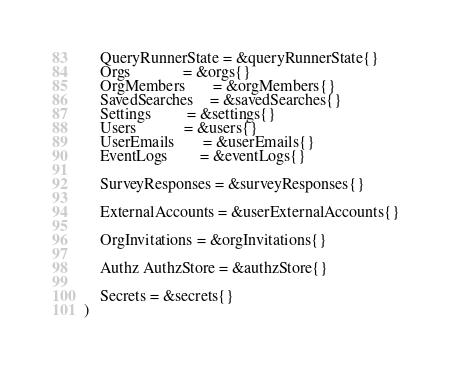Convert code to text. <code><loc_0><loc_0><loc_500><loc_500><_Go_>	QueryRunnerState = &queryRunnerState{}
	Orgs             = &orgs{}
	OrgMembers       = &orgMembers{}
	SavedSearches    = &savedSearches{}
	Settings         = &settings{}
	Users            = &users{}
	UserEmails       = &userEmails{}
	EventLogs        = &eventLogs{}

	SurveyResponses = &surveyResponses{}

	ExternalAccounts = &userExternalAccounts{}

	OrgInvitations = &orgInvitations{}

	Authz AuthzStore = &authzStore{}

	Secrets = &secrets{}
)
</code> 